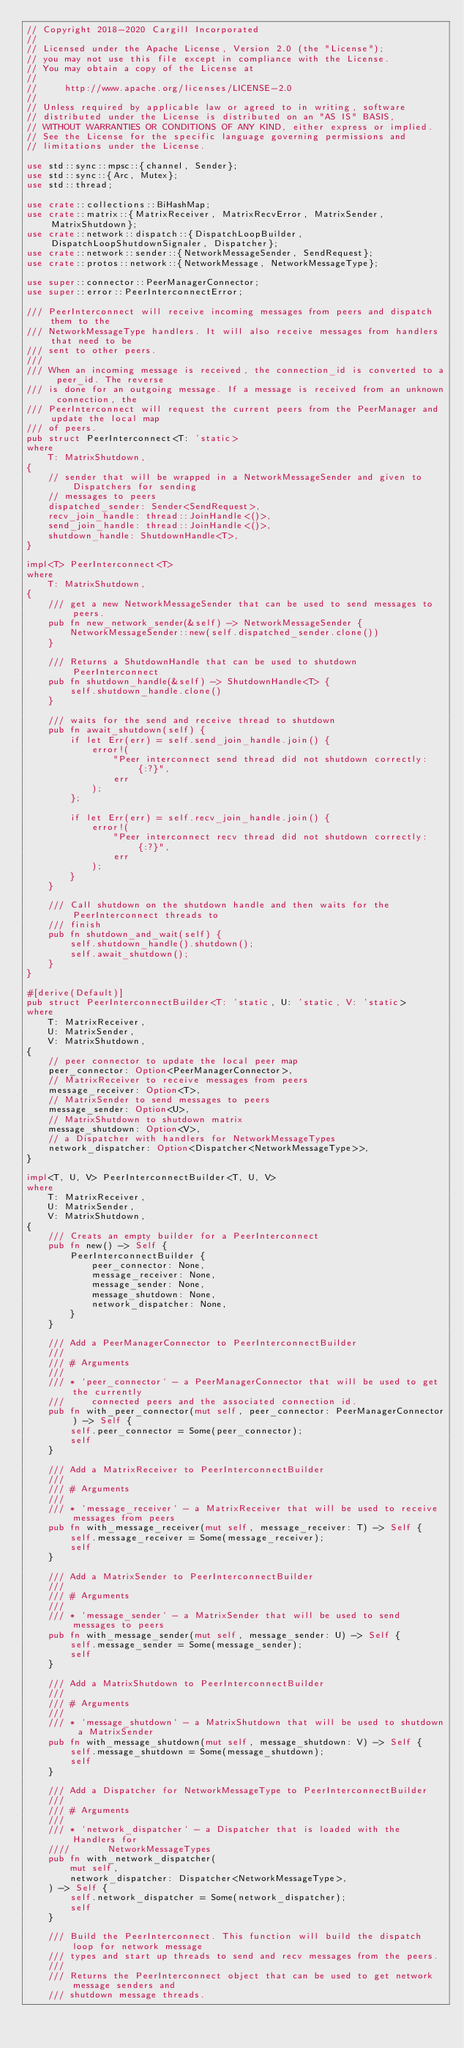Convert code to text. <code><loc_0><loc_0><loc_500><loc_500><_Rust_>// Copyright 2018-2020 Cargill Incorporated
//
// Licensed under the Apache License, Version 2.0 (the "License");
// you may not use this file except in compliance with the License.
// You may obtain a copy of the License at
//
//     http://www.apache.org/licenses/LICENSE-2.0
//
// Unless required by applicable law or agreed to in writing, software
// distributed under the License is distributed on an "AS IS" BASIS,
// WITHOUT WARRANTIES OR CONDITIONS OF ANY KIND, either express or implied.
// See the License for the specific language governing permissions and
// limitations under the License.

use std::sync::mpsc::{channel, Sender};
use std::sync::{Arc, Mutex};
use std::thread;

use crate::collections::BiHashMap;
use crate::matrix::{MatrixReceiver, MatrixRecvError, MatrixSender, MatrixShutdown};
use crate::network::dispatch::{DispatchLoopBuilder, DispatchLoopShutdownSignaler, Dispatcher};
use crate::network::sender::{NetworkMessageSender, SendRequest};
use crate::protos::network::{NetworkMessage, NetworkMessageType};

use super::connector::PeerManagerConnector;
use super::error::PeerInterconnectError;

/// PeerInterconnect will receive incoming messages from peers and dispatch them to the
/// NetworkMessageType handlers. It will also receive messages from handlers that need to be
/// sent to other peers.
///
/// When an incoming message is received, the connection_id is converted to a peer_id. The reverse
/// is done for an outgoing message. If a message is received from an unknown connection, the
/// PeerInterconnect will request the current peers from the PeerManager and update the local map
/// of peers.
pub struct PeerInterconnect<T: 'static>
where
    T: MatrixShutdown,
{
    // sender that will be wrapped in a NetworkMessageSender and given to Dispatchers for sending
    // messages to peers
    dispatched_sender: Sender<SendRequest>,
    recv_join_handle: thread::JoinHandle<()>,
    send_join_handle: thread::JoinHandle<()>,
    shutdown_handle: ShutdownHandle<T>,
}

impl<T> PeerInterconnect<T>
where
    T: MatrixShutdown,
{
    /// get a new NetworkMessageSender that can be used to send messages to peers.
    pub fn new_network_sender(&self) -> NetworkMessageSender {
        NetworkMessageSender::new(self.dispatched_sender.clone())
    }

    /// Returns a ShutdownHandle that can be used to shutdown PeerInterconnect
    pub fn shutdown_handle(&self) -> ShutdownHandle<T> {
        self.shutdown_handle.clone()
    }

    /// waits for the send and receive thread to shutdown
    pub fn await_shutdown(self) {
        if let Err(err) = self.send_join_handle.join() {
            error!(
                "Peer interconnect send thread did not shutdown correctly: {:?}",
                err
            );
        };

        if let Err(err) = self.recv_join_handle.join() {
            error!(
                "Peer interconnect recv thread did not shutdown correctly: {:?}",
                err
            );
        }
    }

    /// Call shutdown on the shutdown handle and then waits for the PeerInterconnect threads to
    /// finish
    pub fn shutdown_and_wait(self) {
        self.shutdown_handle().shutdown();
        self.await_shutdown();
    }
}

#[derive(Default)]
pub struct PeerInterconnectBuilder<T: 'static, U: 'static, V: 'static>
where
    T: MatrixReceiver,
    U: MatrixSender,
    V: MatrixShutdown,
{
    // peer connector to update the local peer map
    peer_connector: Option<PeerManagerConnector>,
    // MatrixReceiver to receive messages from peers
    message_receiver: Option<T>,
    // MatrixSender to send messages to peers
    message_sender: Option<U>,
    // MatrixShutdown to shutdown matrix
    message_shutdown: Option<V>,
    // a Dispatcher with handlers for NetworkMessageTypes
    network_dispatcher: Option<Dispatcher<NetworkMessageType>>,
}

impl<T, U, V> PeerInterconnectBuilder<T, U, V>
where
    T: MatrixReceiver,
    U: MatrixSender,
    V: MatrixShutdown,
{
    /// Creats an empty builder for a PeerInterconnect
    pub fn new() -> Self {
        PeerInterconnectBuilder {
            peer_connector: None,
            message_receiver: None,
            message_sender: None,
            message_shutdown: None,
            network_dispatcher: None,
        }
    }

    /// Add a PeerManagerConnector to PeerInterconnectBuilder
    ///
    /// # Arguments
    ///
    /// * `peer_connector` - a PeerManagerConnector that will be used to get the currently
    ///     connected peers and the associated connection id.
    pub fn with_peer_connector(mut self, peer_connector: PeerManagerConnector) -> Self {
        self.peer_connector = Some(peer_connector);
        self
    }

    /// Add a MatrixReceiver to PeerInterconnectBuilder
    ///
    /// # Arguments
    ///
    /// * `message_receiver` - a MatrixReceiver that will be used to receive messages from peers
    pub fn with_message_receiver(mut self, message_receiver: T) -> Self {
        self.message_receiver = Some(message_receiver);
        self
    }

    /// Add a MatrixSender to PeerInterconnectBuilder
    ///
    /// # Arguments
    ///
    /// * `message_sender` - a MatrixSender that will be used to send messages to peers
    pub fn with_message_sender(mut self, message_sender: U) -> Self {
        self.message_sender = Some(message_sender);
        self
    }

    /// Add a MatrixShutdown to PeerInterconnectBuilder
    ///
    /// # Arguments
    ///
    /// * `message_shutdown` - a MatrixShutdown that will be used to shutdown a MatrixSender
    pub fn with_message_shutdown(mut self, message_shutdown: V) -> Self {
        self.message_shutdown = Some(message_shutdown);
        self
    }

    /// Add a Dispatcher for NetworkMessageType to PeerInterconnectBuilder
    ///
    /// # Arguments
    ///
    /// * `network_dispatcher` - a Dispatcher that is loaded with the Handlers for
    ////       NetworkMessageTypes
    pub fn with_network_dispatcher(
        mut self,
        network_dispatcher: Dispatcher<NetworkMessageType>,
    ) -> Self {
        self.network_dispatcher = Some(network_dispatcher);
        self
    }

    /// Build the PeerInterconnect. This function will build the dispatch loop for network message
    /// types and start up threads to send and recv messages from the peers.
    ///
    /// Returns the PeerInterconnect object that can be used to get network message senders and
    /// shutdown message threads.</code> 